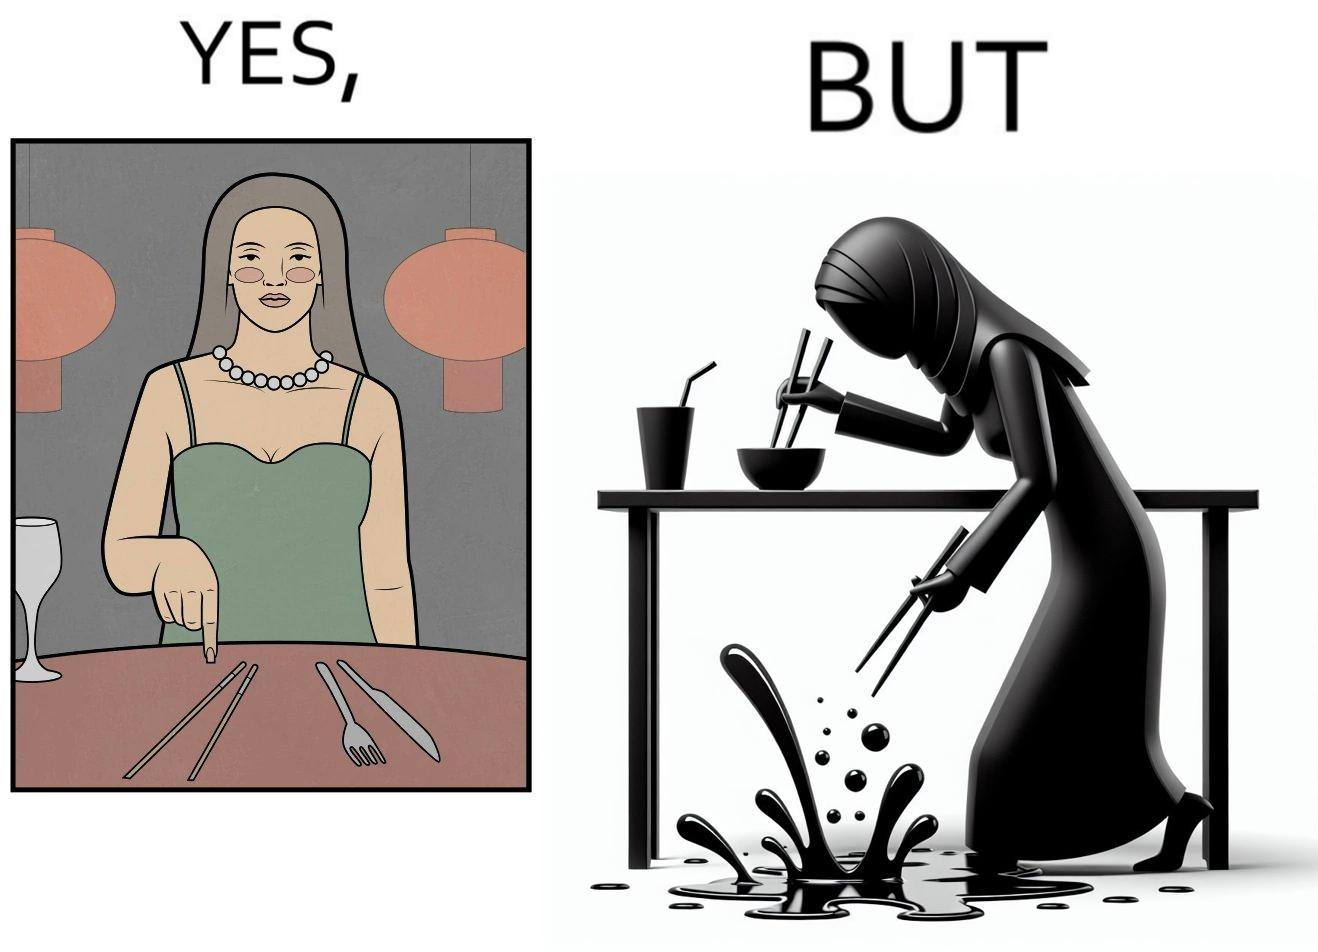Describe what you see in this image. The image is satirical because even thought the woman is not able to eat food with chopstick properly, she chooses it over fork and knife to look sophisticaed. 